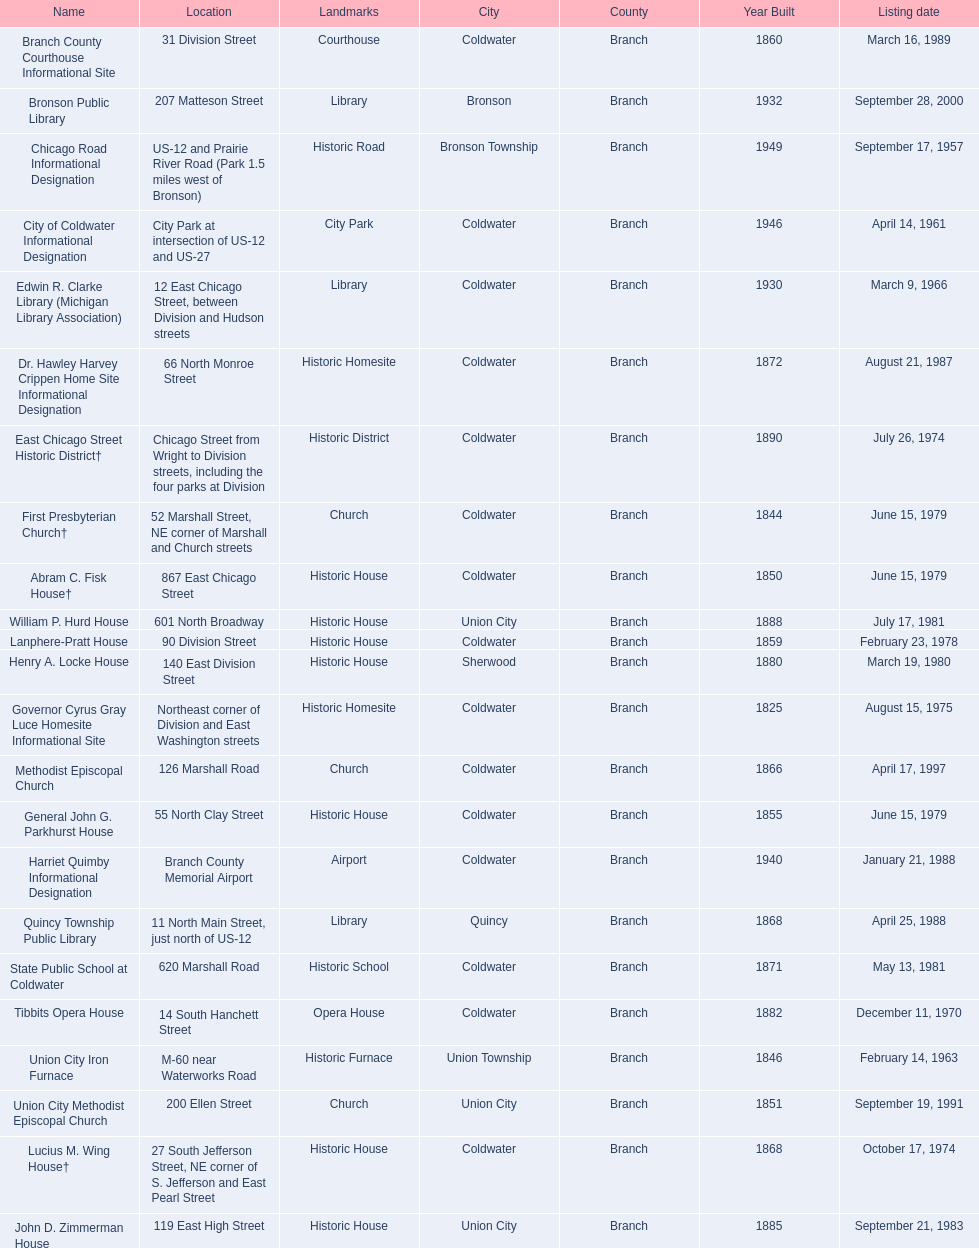In branch co. mi what historic sites are located on a near a highway? Chicago Road Informational Designation, City of Coldwater Informational Designation, Quincy Township Public Library, Union City Iron Furnace. Of the historic sites ins branch co. near highways, which ones are near only us highways? Chicago Road Informational Designation, City of Coldwater Informational Designation, Quincy Township Public Library. Which historical sites in branch co. are near only us highways and are not a building? Chicago Road Informational Designation, City of Coldwater Informational Designation. Which non-building historical sites in branch county near a us highways is closest to bronson? Chicago Road Informational Designation. 